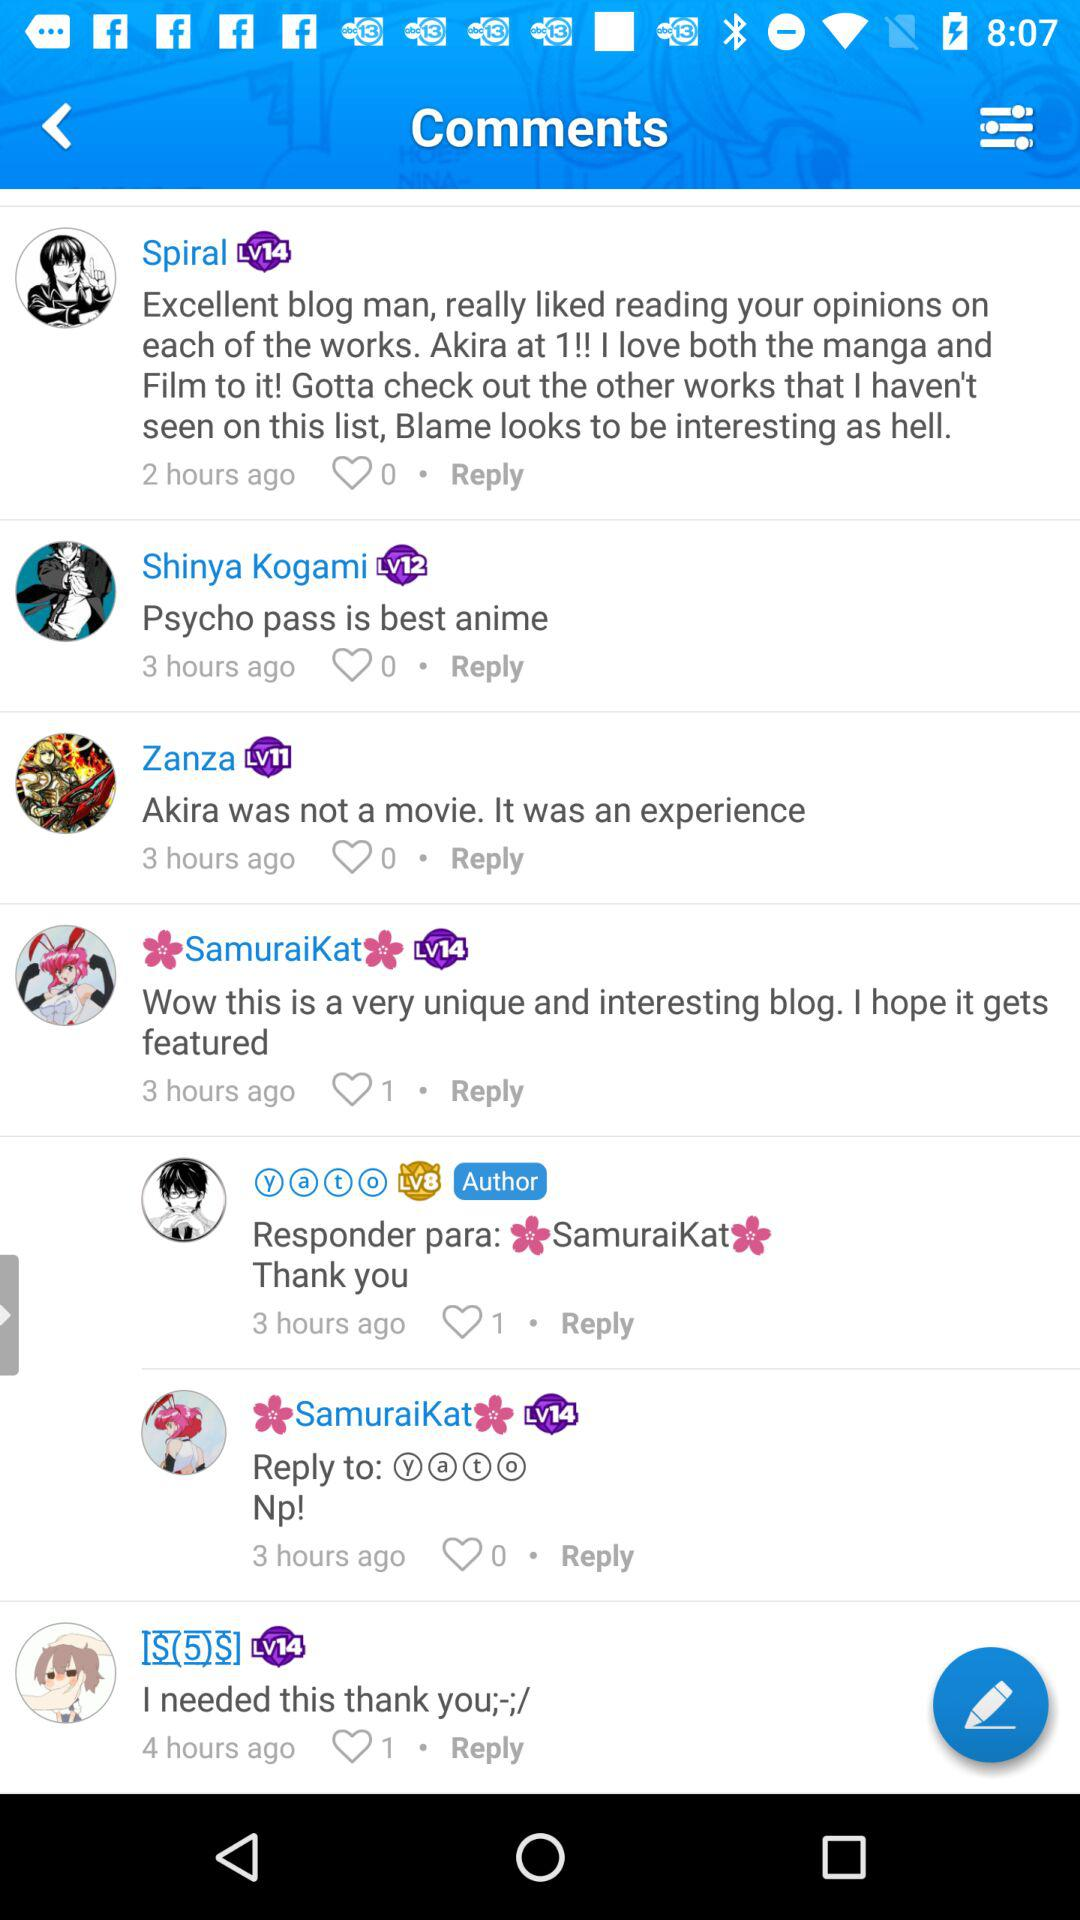How many likes are there on the comment of "SamuraiKat"? There is one like on the comment. 